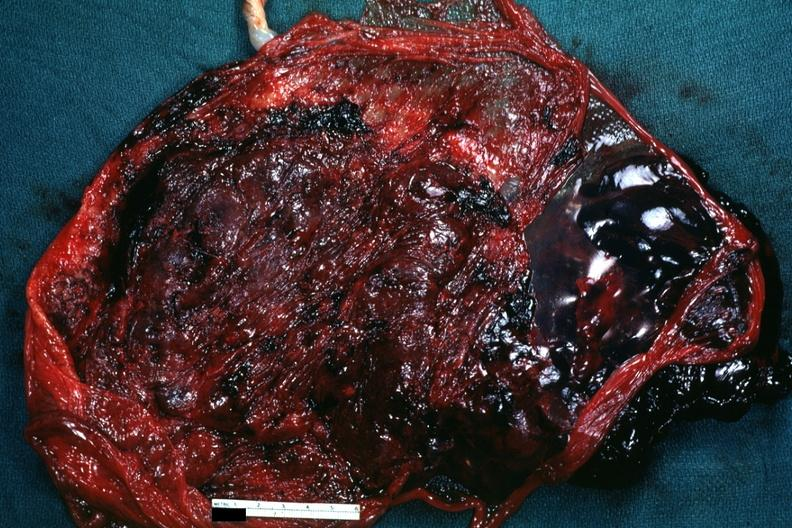s photo present?
Answer the question using a single word or phrase. No 